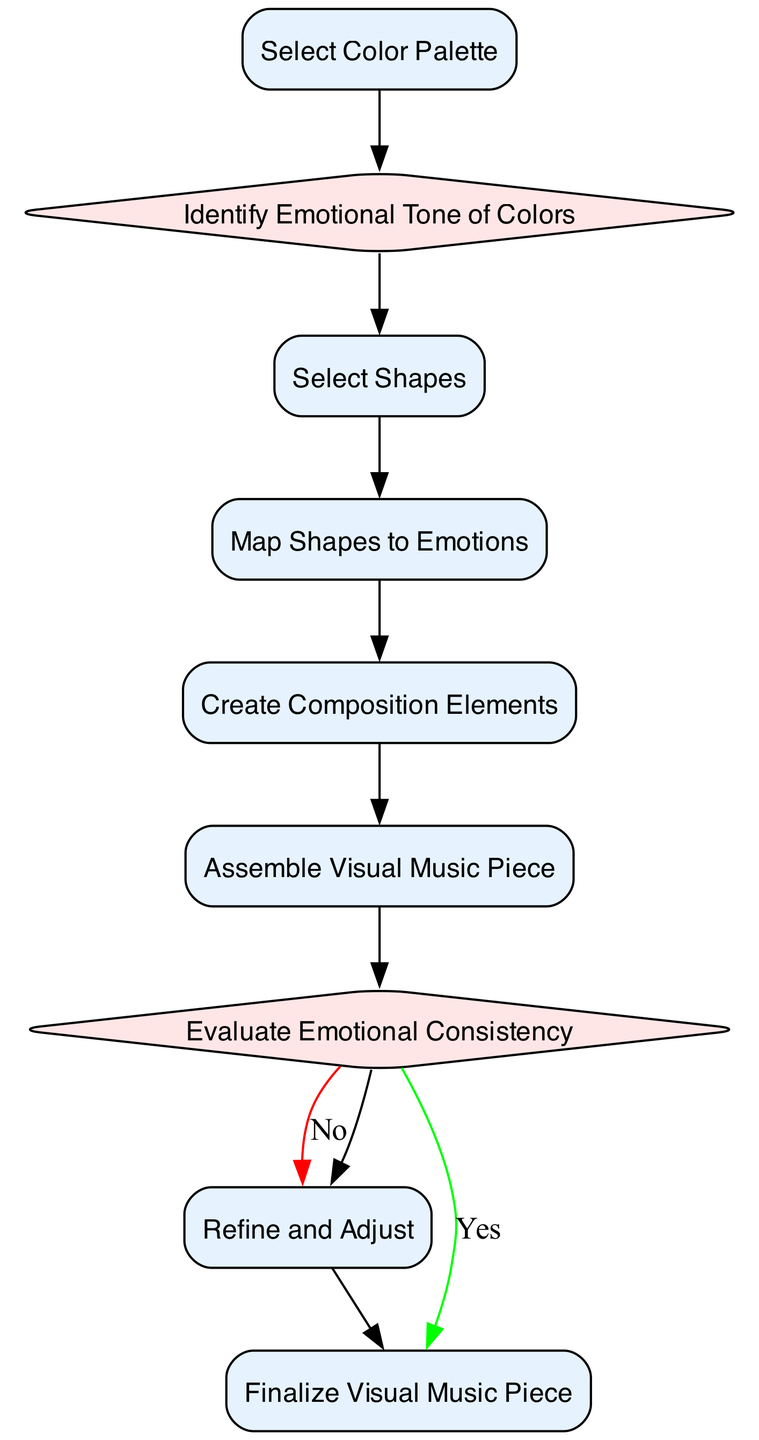What is the first action in the diagram? The first action node in the diagram is "Select Color Palette". This can be identified as it is the initial action from which all subsequent actions and decisions flow.
Answer: Select Color Palette How many decision nodes are present in the diagram? The diagram contains two decision nodes: "Identify Emotional Tone of Colors" and "Evaluate Emotional Consistency". These are identifiable by their diamond shapes, which signify decisions that affect the flow of the diagram.
Answer: 2 What is the outcome path if the answer to "Evaluate Emotional Consistency" is Yes? If the answer is "Yes" to "Evaluate Emotional Consistency", the flow continues to the next node, which is "Finalize Visual Music Piece". This shows the progression if the piece meets the emotional consistency criteria.
Answer: Finalize Visual Music Piece Which action follows "Map Shapes to Emotions"? The action that directly follows "Map Shapes to Emotions" is "Create Composition Elements". This can be seen as a straightforward progression without any intervening decision nodes.
Answer: Create Composition Elements What does the last action node represent in the diagram? The last action node represents "Finalize Visual Music Piece". This indicates the completion stage of the diagram, where all prior actions and decisions culminate into the final product.
Answer: Finalize Visual Music Piece What is the relationship between "Select Shapes" and "Map Shapes to Emotions"? "Select Shapes" leads directly to "Map Shapes to Emotions" as a sequential action. Once shapes are chosen, they are mapped to the corresponding emotions, forming a direct causal relationship in the diagram's flow.
Answer: Sequence What happens if the answer to "Evaluate Emotional Consistency" is No? If the answer is "No" to "Evaluate Emotional Consistency", the flow directs to "Refine and Adjust", indicating that adjustments are necessary before finalization. This reflects a feedback loop for improvement.
Answer: Refine and Adjust What is the total number of nodes in the diagram? The diagram consists of 9 nodes in total, including both action and decision nodes. Each represents a distinct step within the overall process of creating a visual music piece.
Answer: 9 Identify an action that does not precede any decisions. The action "Select Color Palette" is unique as it does not precede any decision nodes. It is the starting point of the diagram and directly leads to subsequent actions.
Answer: Select Color Palette 